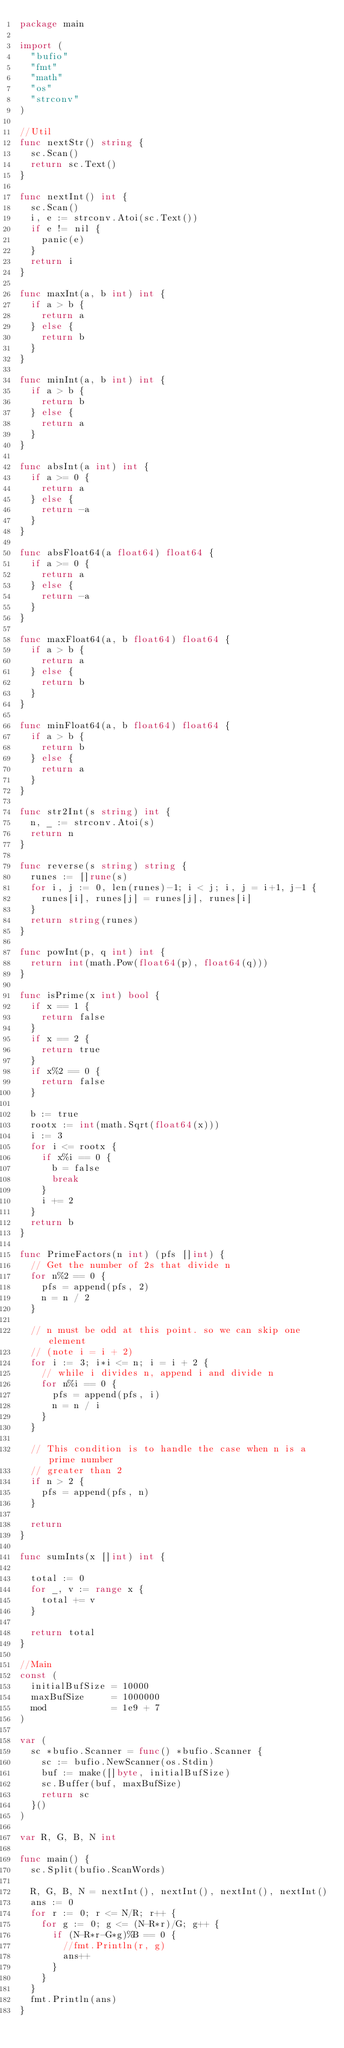<code> <loc_0><loc_0><loc_500><loc_500><_Go_>package main

import (
	"bufio"
	"fmt"
	"math"
	"os"
	"strconv"
)

//Util
func nextStr() string {
	sc.Scan()
	return sc.Text()
}

func nextInt() int {
	sc.Scan()
	i, e := strconv.Atoi(sc.Text())
	if e != nil {
		panic(e)
	}
	return i
}

func maxInt(a, b int) int {
	if a > b {
		return a
	} else {
		return b
	}
}

func minInt(a, b int) int {
	if a > b {
		return b
	} else {
		return a
	}
}

func absInt(a int) int {
	if a >= 0 {
		return a
	} else {
		return -a
	}
}

func absFloat64(a float64) float64 {
	if a >= 0 {
		return a
	} else {
		return -a
	}
}

func maxFloat64(a, b float64) float64 {
	if a > b {
		return a
	} else {
		return b
	}
}

func minFloat64(a, b float64) float64 {
	if a > b {
		return b
	} else {
		return a
	}
}

func str2Int(s string) int {
	n, _ := strconv.Atoi(s)
	return n
}

func reverse(s string) string {
	runes := []rune(s)
	for i, j := 0, len(runes)-1; i < j; i, j = i+1, j-1 {
		runes[i], runes[j] = runes[j], runes[i]
	}
	return string(runes)
}

func powInt(p, q int) int {
	return int(math.Pow(float64(p), float64(q)))
}

func isPrime(x int) bool {
	if x == 1 {
		return false
	}
	if x == 2 {
		return true
	}
	if x%2 == 0 {
		return false
	}

	b := true
	rootx := int(math.Sqrt(float64(x)))
	i := 3
	for i <= rootx {
		if x%i == 0 {
			b = false
			break
		}
		i += 2
	}
	return b
}

func PrimeFactors(n int) (pfs []int) {
	// Get the number of 2s that divide n
	for n%2 == 0 {
		pfs = append(pfs, 2)
		n = n / 2
	}

	// n must be odd at this point. so we can skip one element
	// (note i = i + 2)
	for i := 3; i*i <= n; i = i + 2 {
		// while i divides n, append i and divide n
		for n%i == 0 {
			pfs = append(pfs, i)
			n = n / i
		}
	}

	// This condition is to handle the case when n is a prime number
	// greater than 2
	if n > 2 {
		pfs = append(pfs, n)
	}

	return
}

func sumInts(x []int) int {

	total := 0
	for _, v := range x {
		total += v
	}

	return total
}

//Main
const (
	initialBufSize = 10000
	maxBufSize     = 1000000
	mod            = 1e9 + 7
)

var (
	sc *bufio.Scanner = func() *bufio.Scanner {
		sc := bufio.NewScanner(os.Stdin)
		buf := make([]byte, initialBufSize)
		sc.Buffer(buf, maxBufSize)
		return sc
	}()
)

var R, G, B, N int

func main() {
	sc.Split(bufio.ScanWords)

	R, G, B, N = nextInt(), nextInt(), nextInt(), nextInt()
	ans := 0
	for r := 0; r <= N/R; r++ {
		for g := 0; g <= (N-R*r)/G; g++ {
			if (N-R*r-G*g)%B == 0 {
				//fmt.Println(r, g)
				ans++
			}
		}
	}
	fmt.Println(ans)
}
</code> 